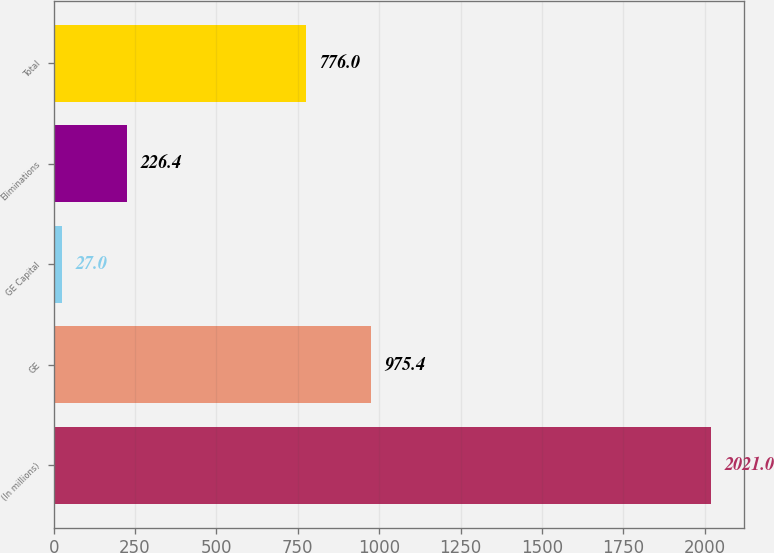Convert chart. <chart><loc_0><loc_0><loc_500><loc_500><bar_chart><fcel>(In millions)<fcel>GE<fcel>GE Capital<fcel>Eliminations<fcel>Total<nl><fcel>2021<fcel>975.4<fcel>27<fcel>226.4<fcel>776<nl></chart> 